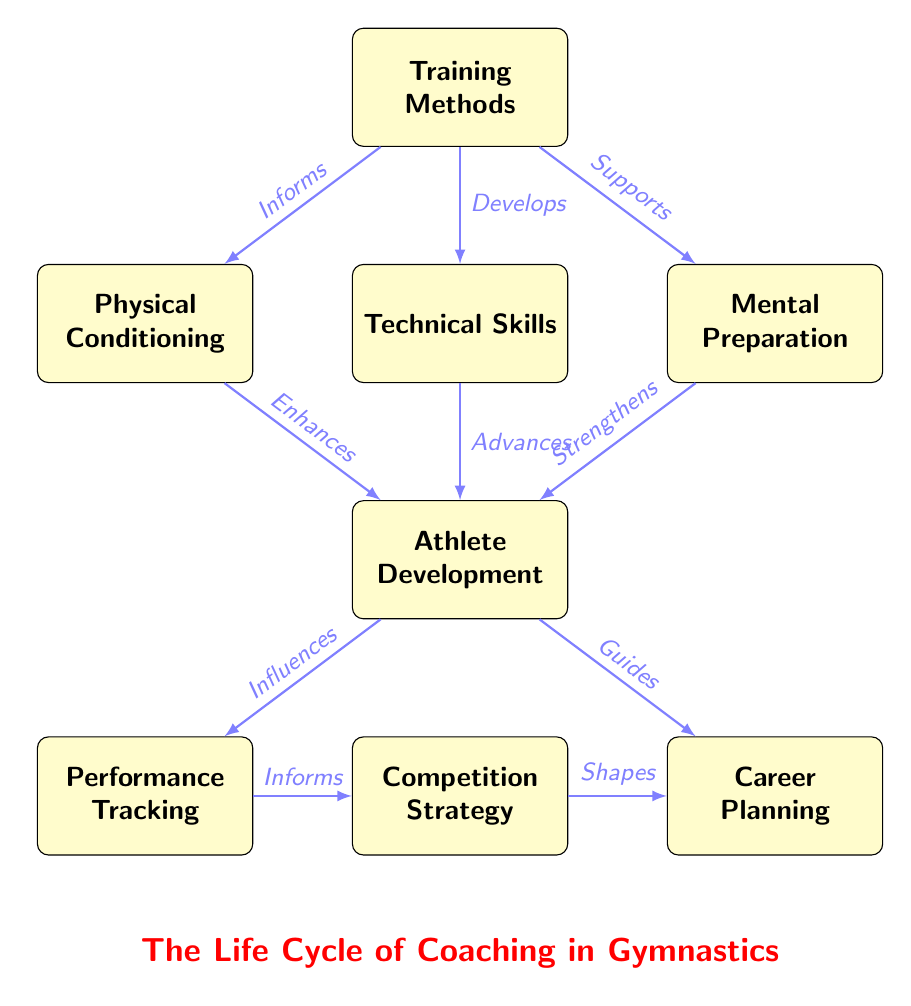What is the first node in the diagram? The diagram starts with the node labeled "Training Methods," which is positioned at the top.
Answer: Training Methods How many nodes are present in the diagram? By counting from the diagram, there are a total of eight nodes displayed.
Answer: 8 Which node does "Physical Conditioning" influence? "Physical Conditioning" enhances "Athlete Development" according to the edge labeled "Enhances."
Answer: Athlete Development What relationship is shown between "Mental Preparation" and "Athlete Development"? The arrow from "Mental Preparation" to "Athlete Development" shows that it strengthens athlete development, indicated by the label "Strengthens."
Answer: Strengthens What does "Performance Tracking" inform? The arrow leading from "Performance Tracking" indicates it informs "Competition Strategy," as labeled in the relationship.
Answer: Competition Strategy How does "Training Methods" support "Mental Preparation"? The edge labeled "Supports" indicates the direct relationship from "Training Methods" to "Mental Preparation."
Answer: Supports What is the final outcome influenced by "Athlete Development"? The diagram shows that "Athlete Development" influences both "Performance Tracking" and "Career Planning." Thus, these are the final outcomes.
Answer: Performance Tracking, Career Planning What is the term indicating the relationship between "Competition Strategy" and "Career Planning"? The edge labeled "Shapes" indicates how "Competition Strategy" shapes "Career Planning."
Answer: Shapes 